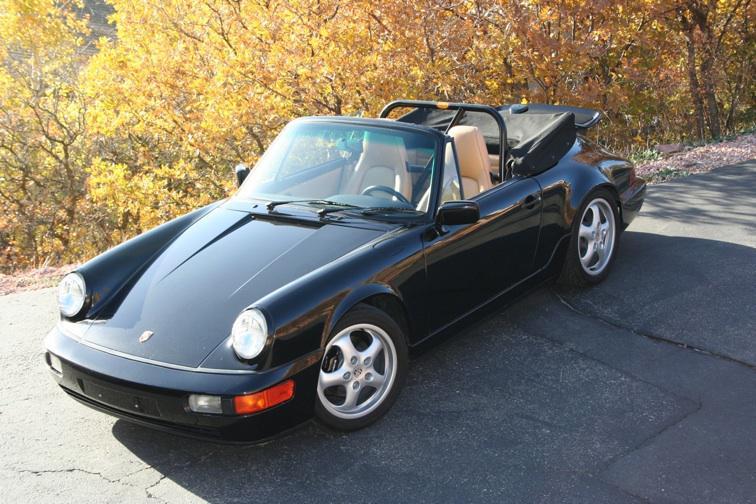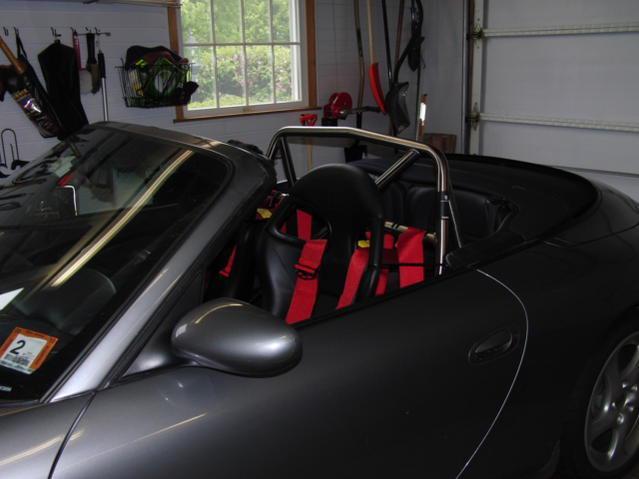The first image is the image on the left, the second image is the image on the right. For the images displayed, is the sentence "The roll bars are visible in the image on the right." factually correct? Answer yes or no. Yes. 